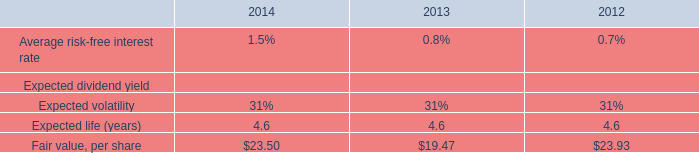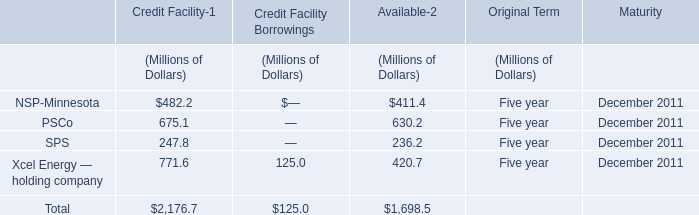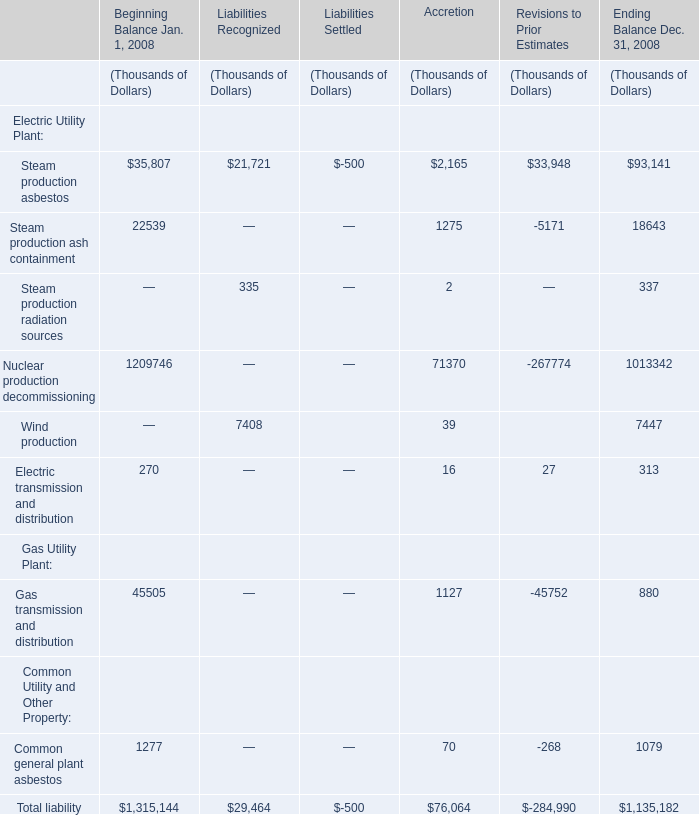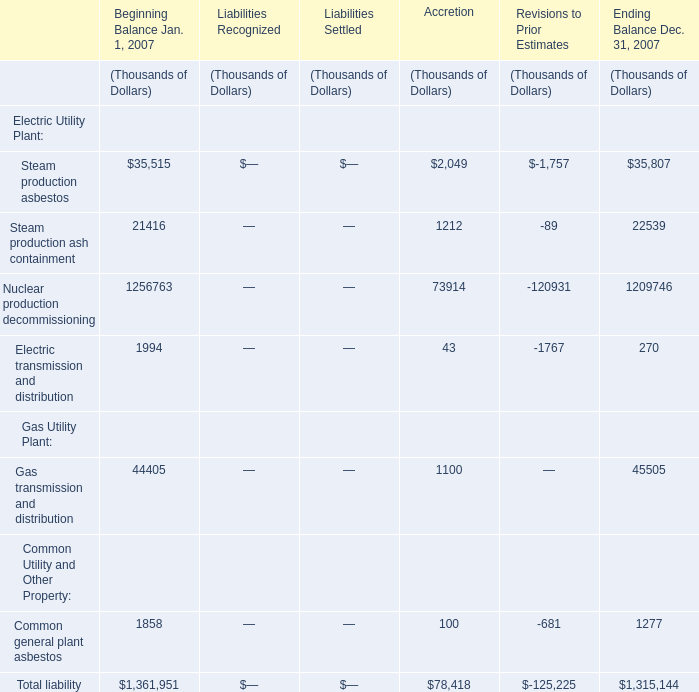Which liability has the second largest number in Beginning Balance Jan. 1, 2007 ? 
Answer: Gas transmission and distribution. 